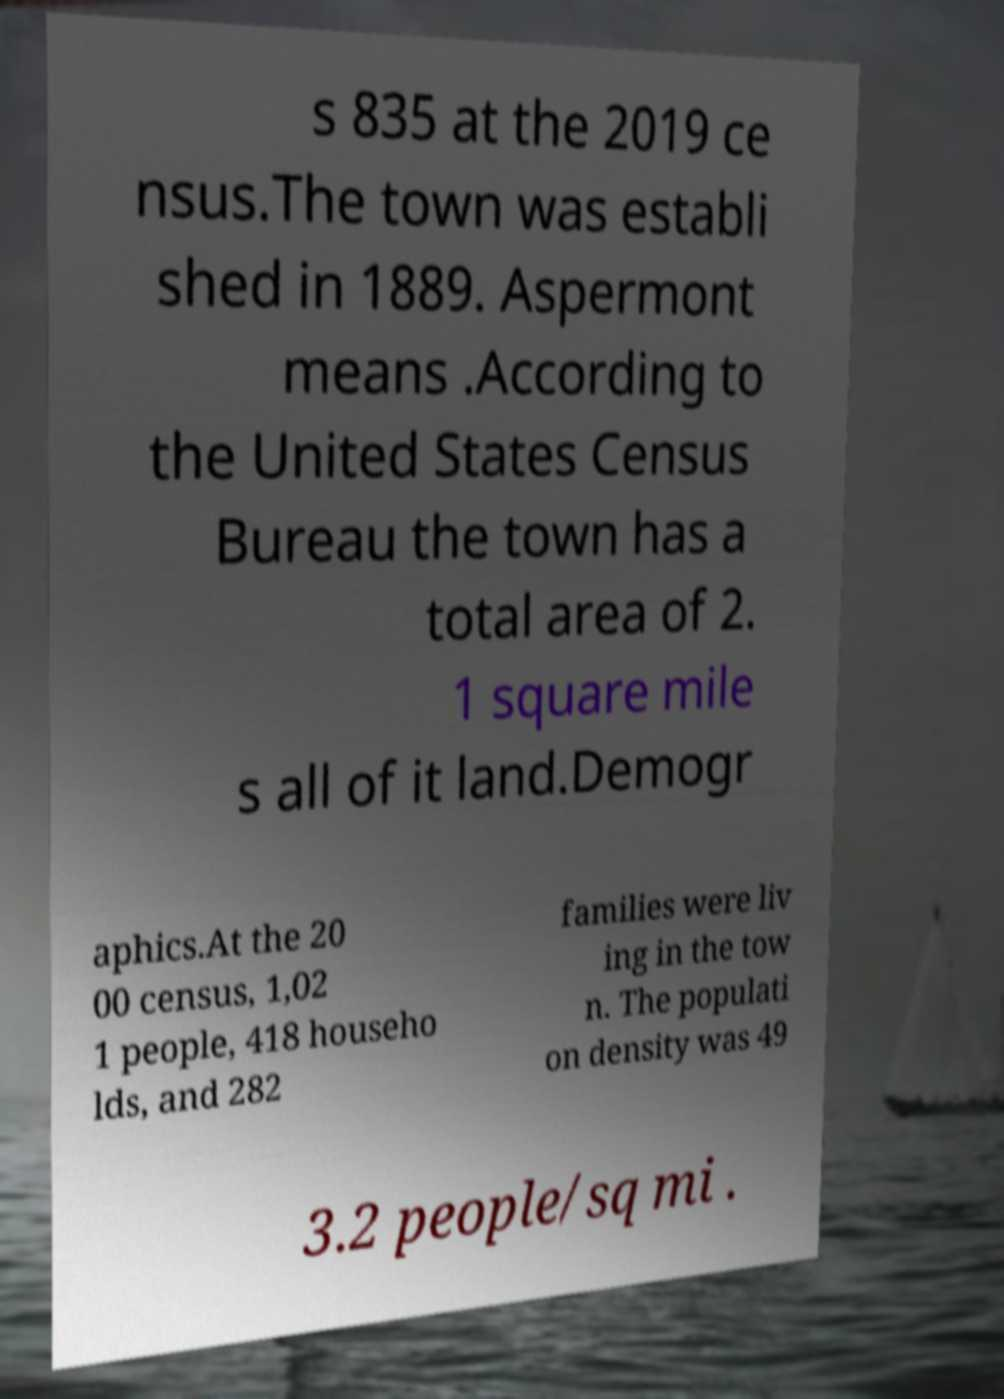Can you read and provide the text displayed in the image?This photo seems to have some interesting text. Can you extract and type it out for me? s 835 at the 2019 ce nsus.The town was establi shed in 1889. Aspermont means .According to the United States Census Bureau the town has a total area of 2. 1 square mile s all of it land.Demogr aphics.At the 20 00 census, 1,02 1 people, 418 househo lds, and 282 families were liv ing in the tow n. The populati on density was 49 3.2 people/sq mi . 